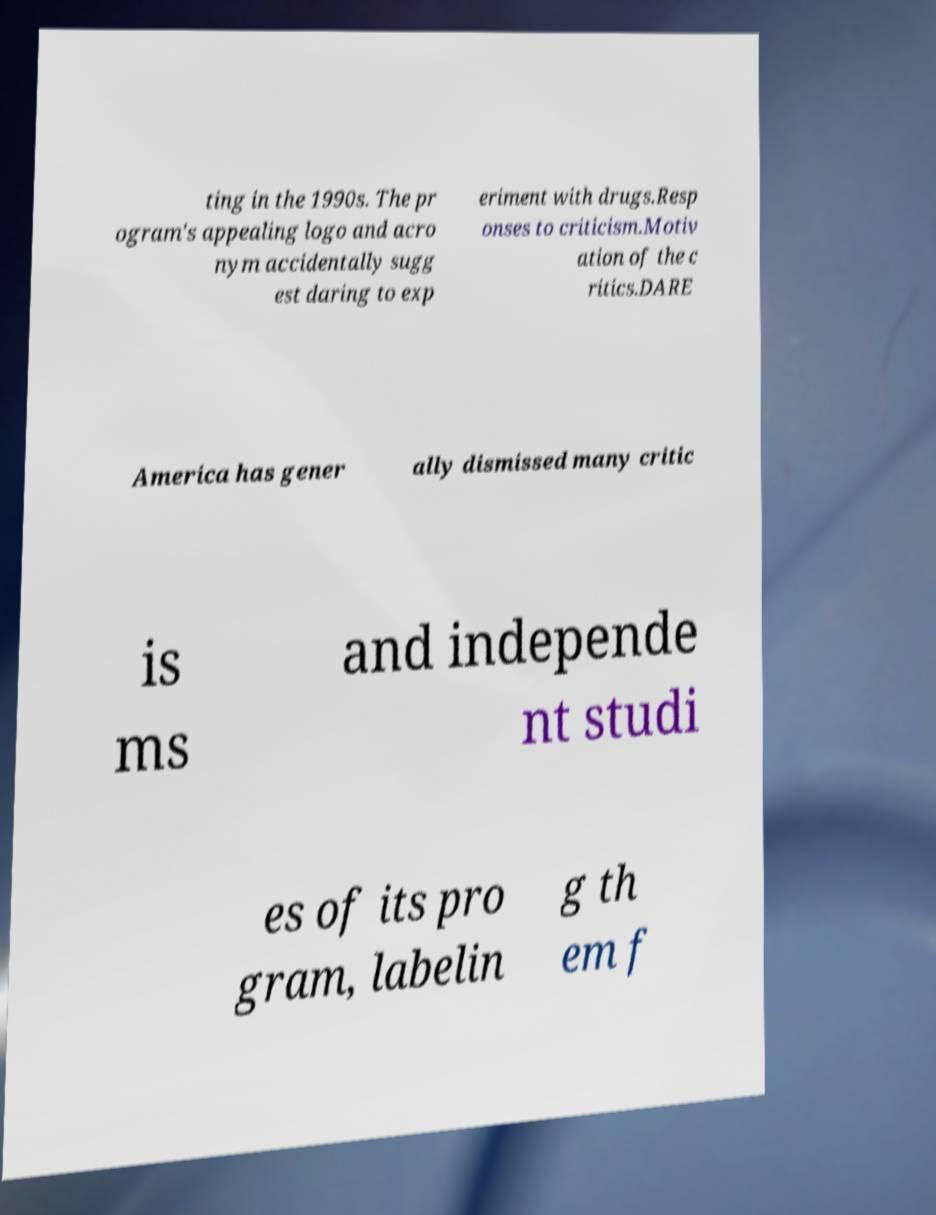There's text embedded in this image that I need extracted. Can you transcribe it verbatim? ting in the 1990s. The pr ogram's appealing logo and acro nym accidentally sugg est daring to exp eriment with drugs.Resp onses to criticism.Motiv ation of the c ritics.DARE America has gener ally dismissed many critic is ms and independe nt studi es of its pro gram, labelin g th em f 